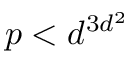<formula> <loc_0><loc_0><loc_500><loc_500>p < d ^ { 3 d ^ { 2 } }</formula> 